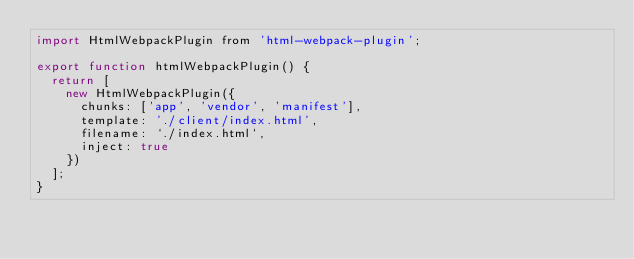<code> <loc_0><loc_0><loc_500><loc_500><_JavaScript_>import HtmlWebpackPlugin from 'html-webpack-plugin';

export function htmlWebpackPlugin() {
  return [
    new HtmlWebpackPlugin({
      chunks: ['app', 'vendor', 'manifest'],
      template: './client/index.html',
      filename: `./index.html`,
      inject: true
    })
  ];
}</code> 